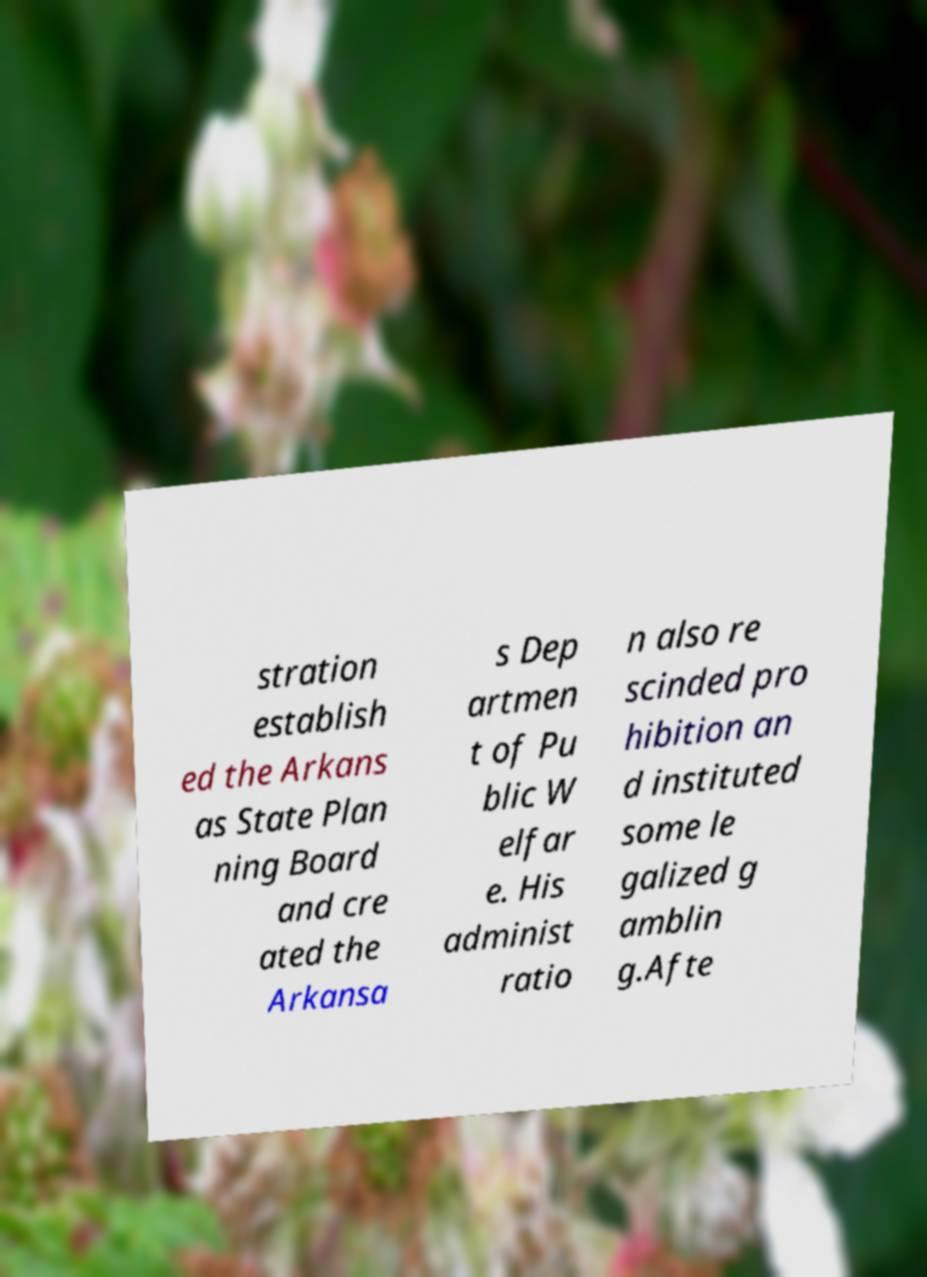Could you extract and type out the text from this image? stration establish ed the Arkans as State Plan ning Board and cre ated the Arkansa s Dep artmen t of Pu blic W elfar e. His administ ratio n also re scinded pro hibition an d instituted some le galized g amblin g.Afte 